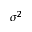<formula> <loc_0><loc_0><loc_500><loc_500>\sigma ^ { 2 }</formula> 